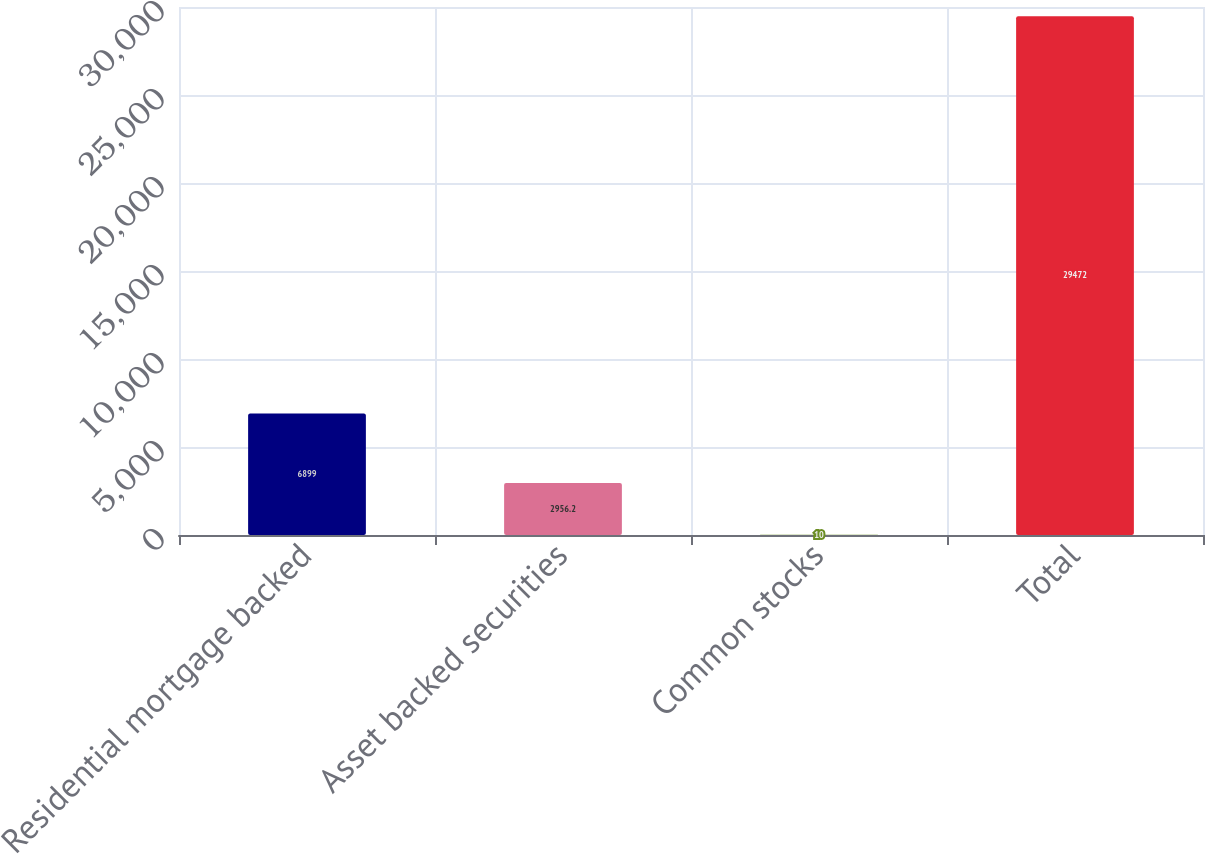Convert chart. <chart><loc_0><loc_0><loc_500><loc_500><bar_chart><fcel>Residential mortgage backed<fcel>Asset backed securities<fcel>Common stocks<fcel>Total<nl><fcel>6899<fcel>2956.2<fcel>10<fcel>29472<nl></chart> 